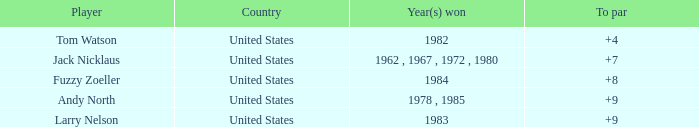In which country does the player with a cumulative score below 153 and a winning year of 1984 originate? United States. 